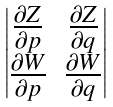Convert formula to latex. <formula><loc_0><loc_0><loc_500><loc_500>\begin{vmatrix} \frac { \partial Z } { \partial p } & \frac { \partial Z } { \partial q } \\ \frac { \partial W } { \partial p } & \frac { \partial W } { \partial q } \end{vmatrix}</formula> 